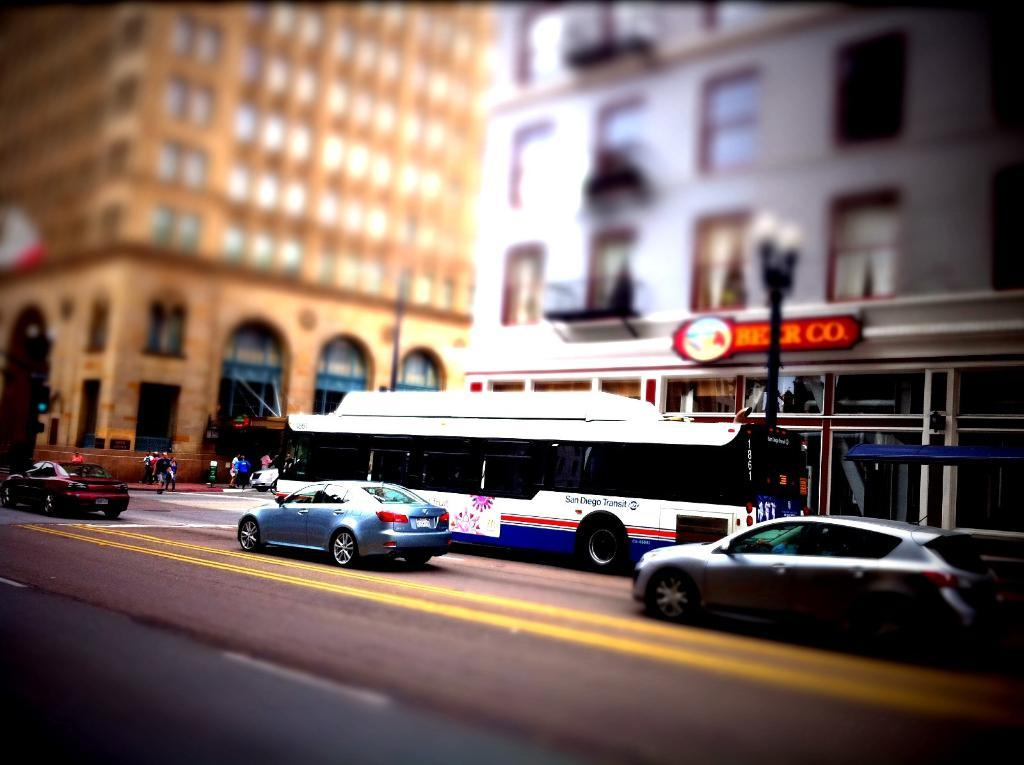What can be seen on the road in the image? There are vehicles on the road in the image. What is visible in the background of the image? There are buildings, poles, a hoarding, and a group of people in the background of the image. What type of fowl can be seen flying over the vehicles in the image? There is no fowl visible in the image; it only shows vehicles on the road and various elements in the background. Can you tell me how many loaves of bread are being held by the group of people in the image? There is no bread present in the image, and the group of people is not holding any items. 